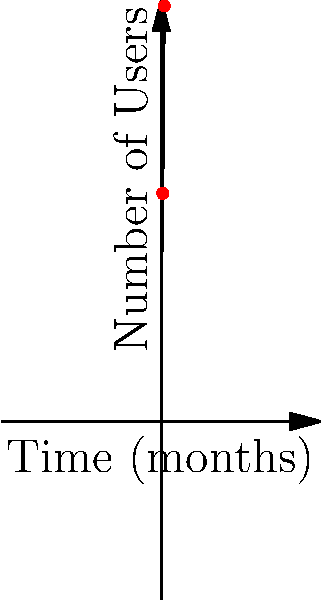The graph shows the exponential growth of users for your new app over time. If the number of users after 12 months is approximately 1,820, what is the estimated number of users after 24 months? Round your answer to the nearest hundred. To solve this problem, we'll use the properties of exponential growth:

1. Identify the exponential growth formula: $N(t) = N_0 \cdot e^{rt}$, where:
   $N(t)$ is the number of users at time $t$
   $N_0$ is the initial number of users
   $r$ is the growth rate
   $t$ is the time in months

2. We know that at $t=12$ months, $N(12) \approx 1,820$ users.

3. To find the number of users at 24 months, we need to recognize that the time has doubled. In exponential growth, when the time doubles, the value is squared.

4. Therefore, $N(24) \approx [N(12)]^2$

5. Calculate: $N(24) \approx 1,820^2 = 3,312,400$

6. Round to the nearest hundred: 3,312,400 ≈ 3,312,400

This method provides a quick estimation without needing to calculate the exact growth rate. It's particularly useful for exponential growth scenarios like app user acquisition.
Answer: 3,312,400 users 